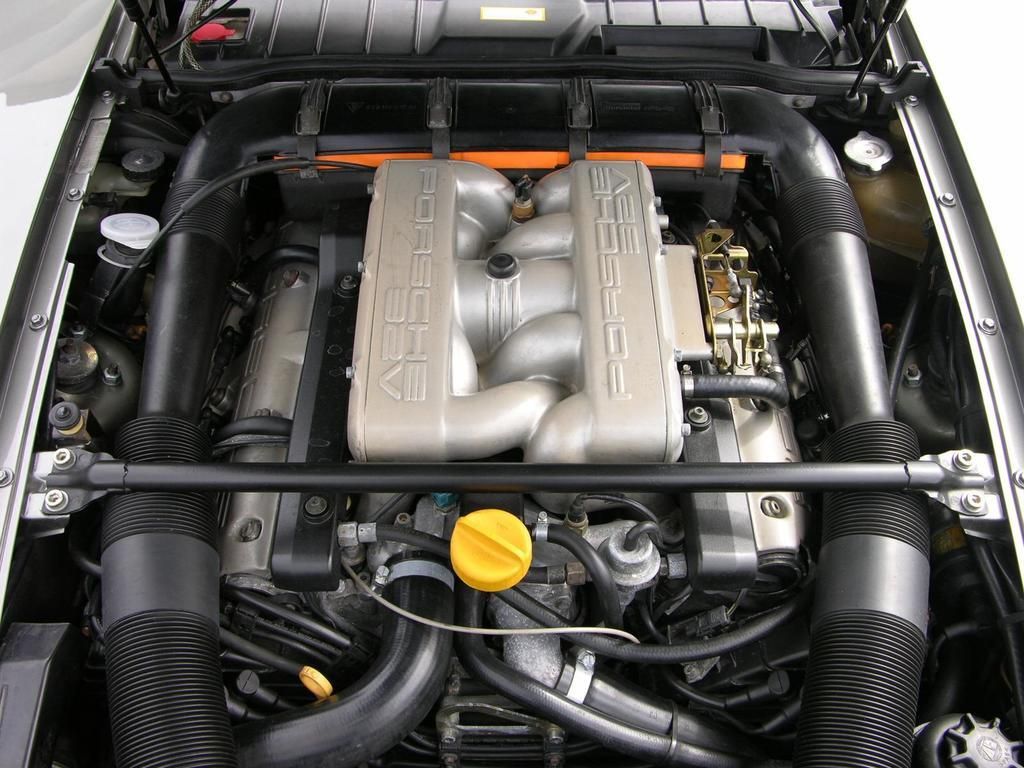What is the main subject of the image? The main subject of the image is a car engine. Can you describe the car engine in the image? Unfortunately, the facts provided do not give any specific details about the car engine. However, we can confirm that it is the primary focus of the image. How many chairs are placed around the queen in the image? There are no chairs or queens present in the image; it features a car engine. 